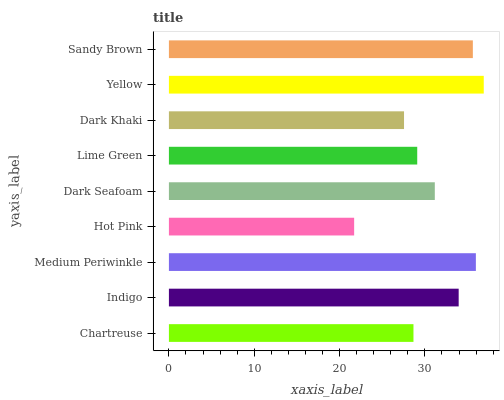Is Hot Pink the minimum?
Answer yes or no. Yes. Is Yellow the maximum?
Answer yes or no. Yes. Is Indigo the minimum?
Answer yes or no. No. Is Indigo the maximum?
Answer yes or no. No. Is Indigo greater than Chartreuse?
Answer yes or no. Yes. Is Chartreuse less than Indigo?
Answer yes or no. Yes. Is Chartreuse greater than Indigo?
Answer yes or no. No. Is Indigo less than Chartreuse?
Answer yes or no. No. Is Dark Seafoam the high median?
Answer yes or no. Yes. Is Dark Seafoam the low median?
Answer yes or no. Yes. Is Sandy Brown the high median?
Answer yes or no. No. Is Medium Periwinkle the low median?
Answer yes or no. No. 